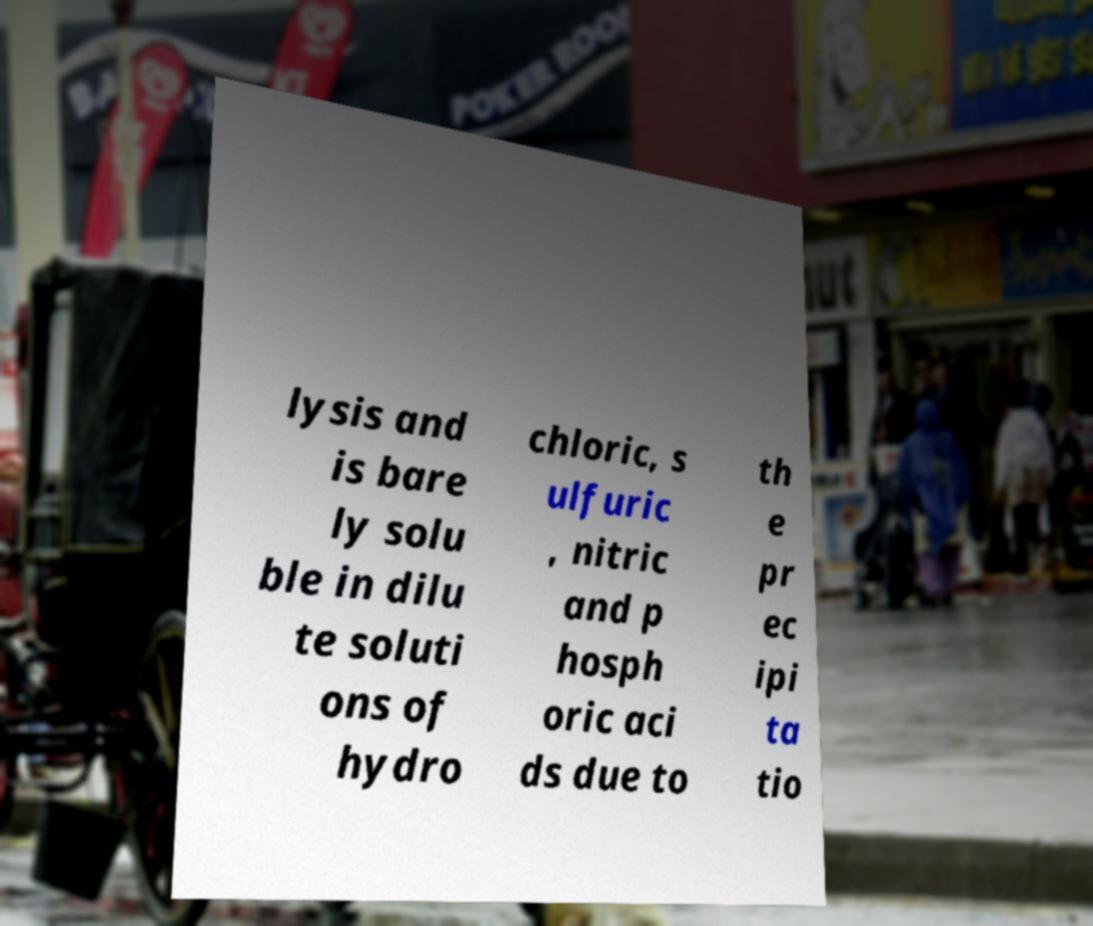Could you assist in decoding the text presented in this image and type it out clearly? lysis and is bare ly solu ble in dilu te soluti ons of hydro chloric, s ulfuric , nitric and p hosph oric aci ds due to th e pr ec ipi ta tio 